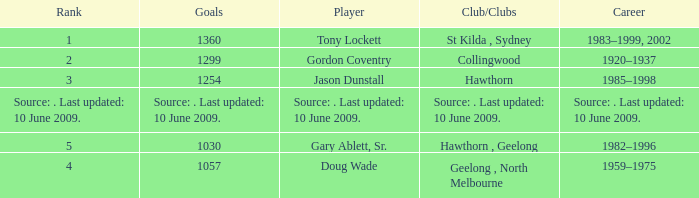In what club(s) does Tony Lockett play? St Kilda , Sydney. 